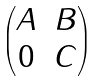Convert formula to latex. <formula><loc_0><loc_0><loc_500><loc_500>\begin{pmatrix} A & B \\ 0 & C \end{pmatrix}</formula> 